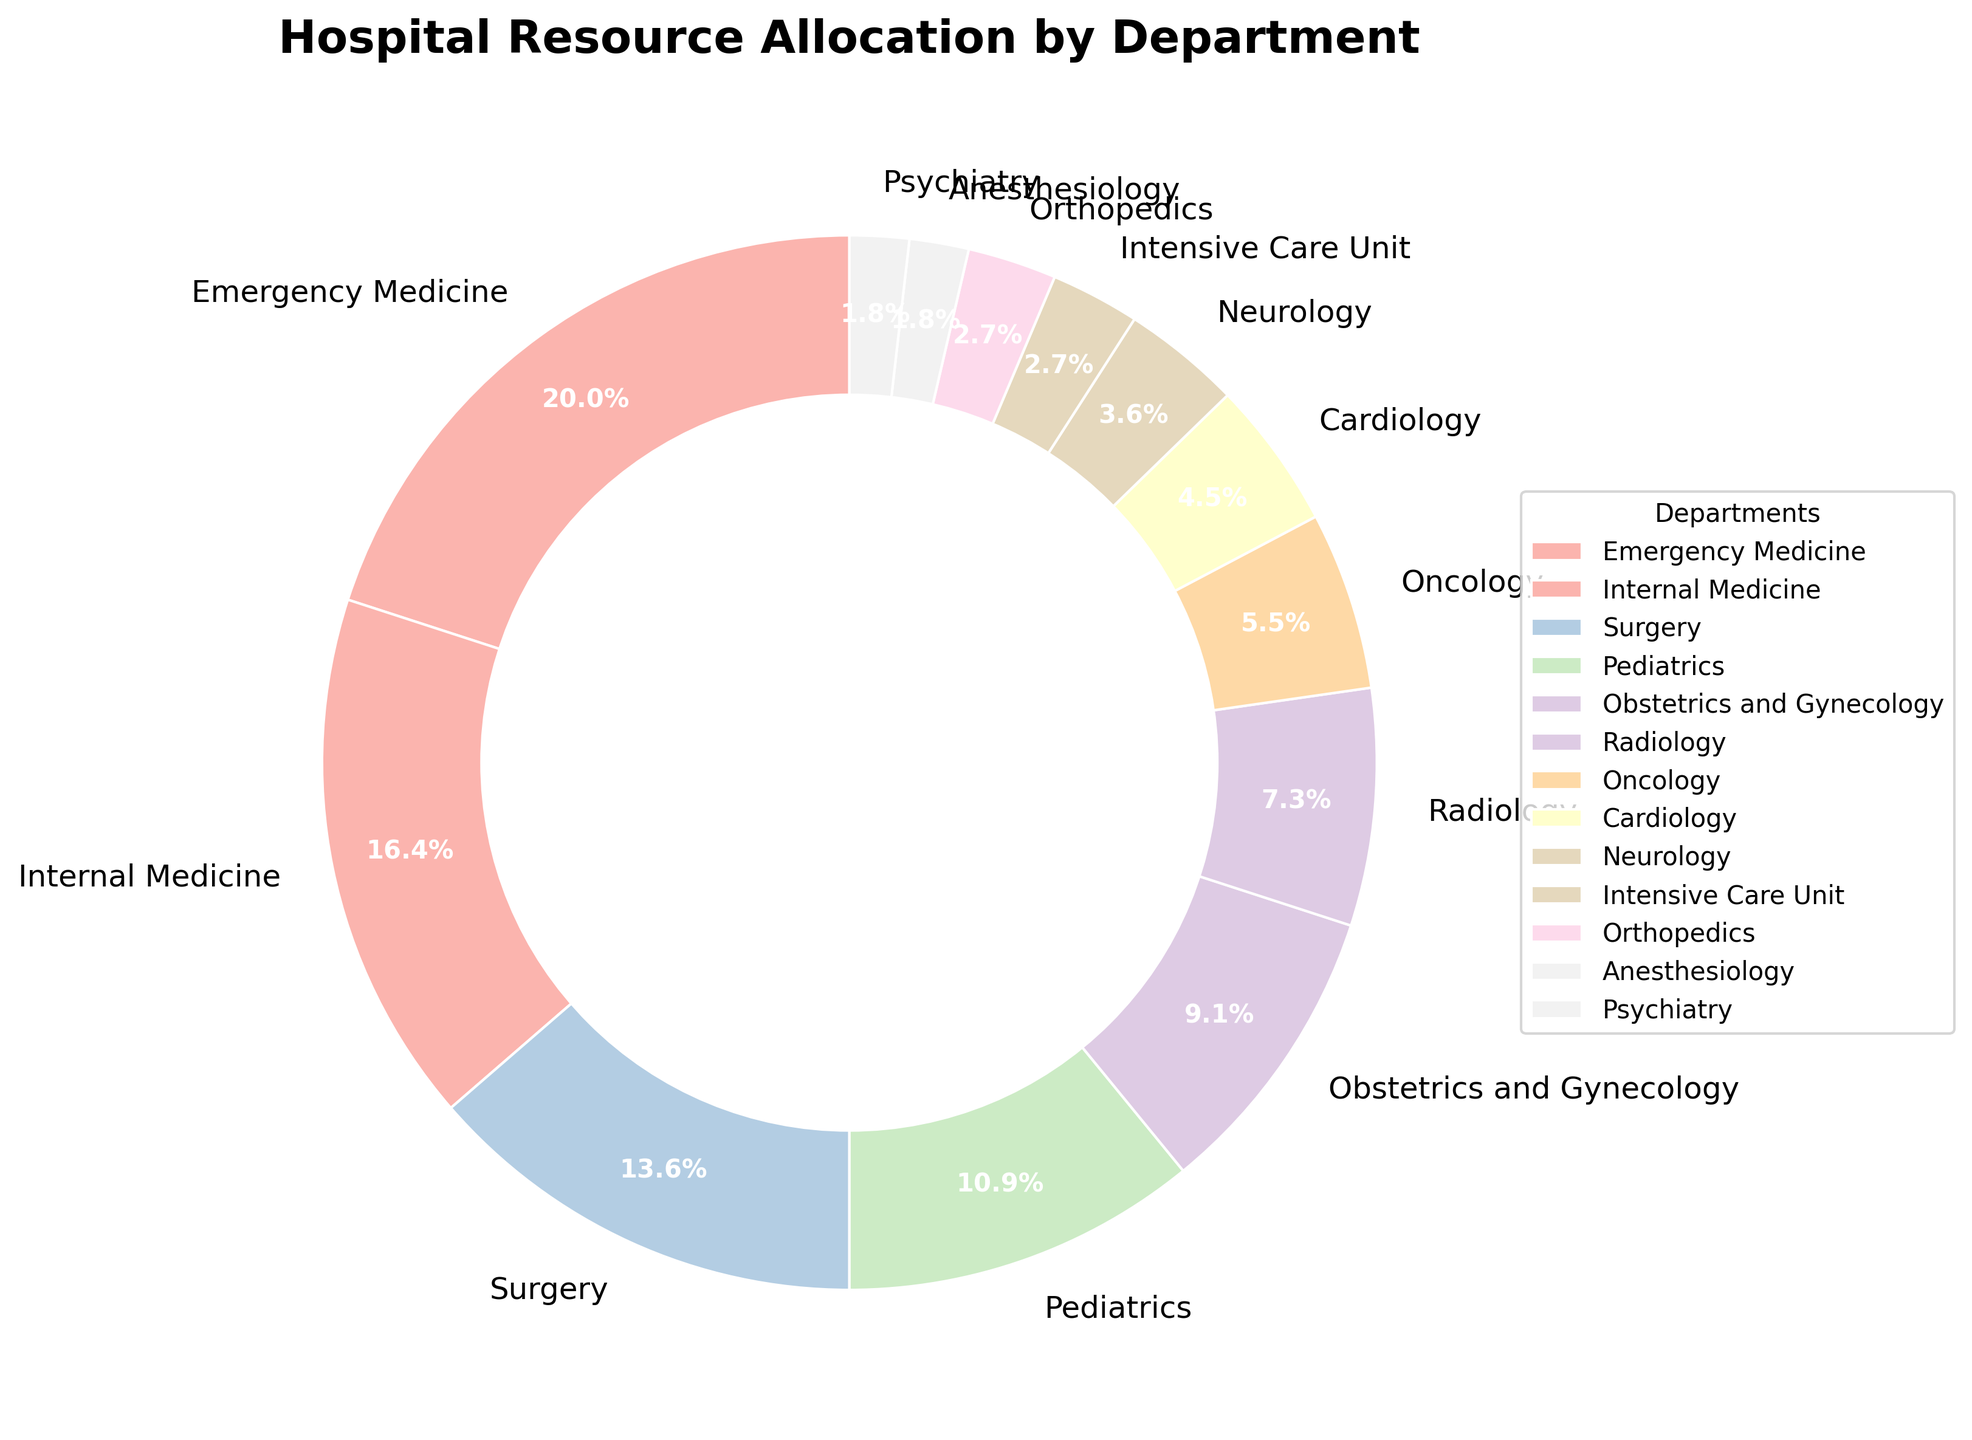Which department receives the highest budget allocation? The pie chart shows the budget allocation for each department. The Emergency Medicine department is the largest slice.
Answer: Emergency Medicine How does Internal Medicine's budget allocation compare to Surgery's? Internal Medicine's allocation is 18%, while Surgery's is 15%. 18% > 15%, so Internal Medicine has a higher allocation.
Answer: Internal Medicine has a higher allocation than Surgery Which department has the smallest allocation? The pie chart shows Psychiatry with the smallest percentage of 2%.
Answer: Psychiatry How much more is allocated to Emergency Medicine than Oncology? Emergency Medicine has 22%, and Oncology has 6%. The difference is 22% - 6% = 16%.
Answer: 16% What is the total budget allocation for departments with less than 10% each? Add the allocations for Radiology (8%), Oncology (6%), Cardiology (5%), Neurology (4%), Intensive Care Unit (3%), Orthopedics (3%), Anesthesiology (2%), Psychiatry (2%). This totals 8% + 6% + 5% + 4% + 3% + 3% + 2% + 2% = 33%.
Answer: 33% Are there any departments allocated more than 20%? Emergency Medicine's slice indicates 22%, which is above 20%.
Answer: Yes What is the average allocation percentage for all departments? Sum all the percentages and divide by the number of departments. The sum is 100%. There are 13 departments. So, 100% / 13 ≈ 7.7%.
Answer: 7.7% Does Pediatrics receive more funding than Radiology and Psychiatry combined? Pediatrics receives 12%. Combined, Radiology (8%) and Psychiatry (2%) sum to 10%. 12% > 10%.
Answer: Yes 